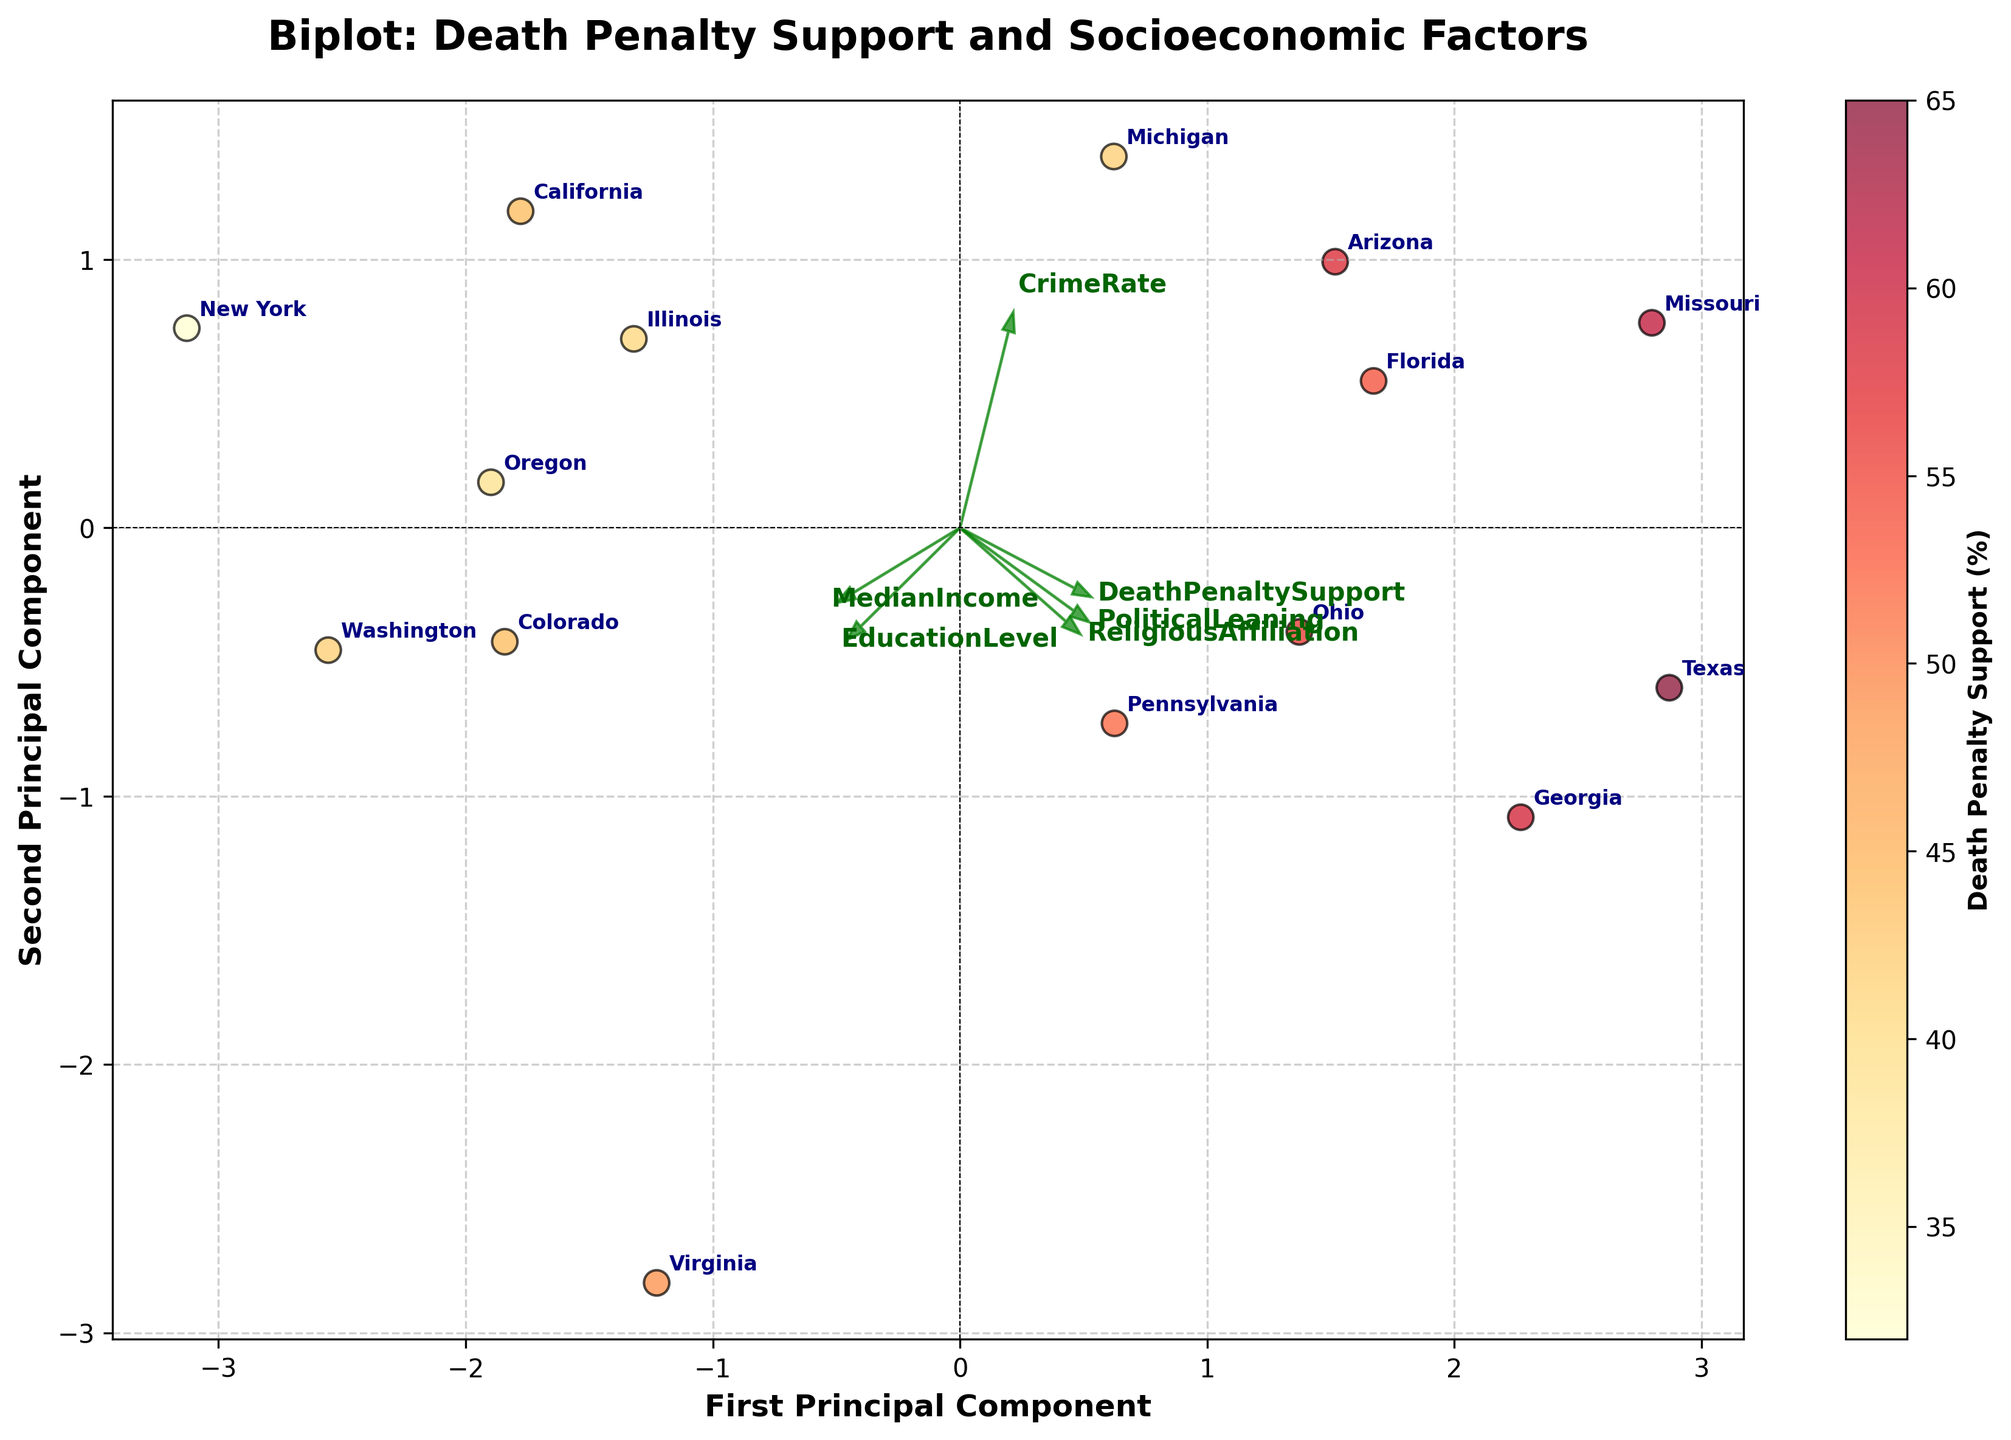What's the title of the figure? The title of the figure is usually located at the top and provides an overview of what the plot is about. In this case, the title is 'Biplot: Death Penalty Support and Socioeconomic Factors.'
Answer: Biplot: Death Penalty Support and Socioeconomic Factors How many states are represented in the plot? Each state is labeled on the plot, and one can count the individual state labels to determine the total number of states. In this case, there are 15 states represented.
Answer: 15 Which state supports the death penalty the most? By looking at the color intensity (YlOrRd colormap) of the data points, the state with the highest support for the death penalty will have the darkest red color. Here, Texas and Missouri are the states with the highest support, indicated by the darkest colors.
Answer: Texas and Missouri Which socioeconomic factor is most strongly correlated with the first Principal Component (PC1)? To determine this, observe which arrow representing a factor is longest along the horizontal axis (PC1). Here, 'MedianIncome' and 'EducationLevel' arrows are most elongated horizontally, indicating a strong correlation with PC1.
Answer: MedianIncome and EducationLevel Is the CrimeRate more correlated with the first or the second Principal Component? By examining the arrow representing 'CrimeRate,' one notes its direction and length relative to the axes. The arrow for 'CrimeRate' extends more along the PC2 axis (vertical) than PC1 (horizontal).
Answer: Second Principal Component Which state is the outlier in terms of the Second Principal Component (PC2)? An outlier can be identified by looking for a state far away from others along the vertical axis (PC2). Virginia is significantly higher along the PC2 axis compared to other states.
Answer: Virginia How does ReligiousAffiliation correlate with Death Penalty Support according to the PCA arrows? By inspecting the arrows, we can see that 'ReligiousAffiliation' and 'DeathPenaltySupport' arrows point in similar directions, suggesting a positive correlation.
Answer: Positively correlated Which two states have a similar representation according to the PCA components? States in close proximity on the plot have similar representations. Here, icons for Florida and Arizona are quite close to each other on the plot.
Answer: Florida and Arizona Compare the Death Penalty Support between California and Michigan. Examine the colors of the data points for these states, where a higher Death Penalty Support corresponds to a darker red. Michigan has a slightly darker color compared to California, indicating higher support.
Answer: Michigan has higher support than California 